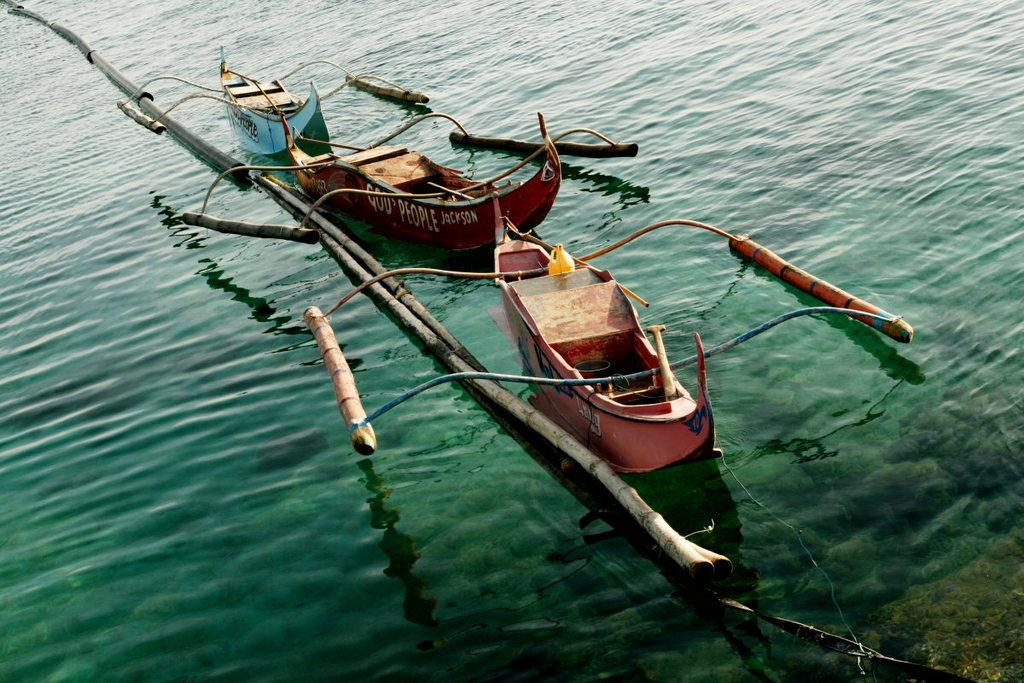How many boats are visible in the image? There are three boats in the image. Where are the boats located? The boats are on the water. What else can be seen near the boats? There are logs beside the boats. Where is the desk located in the image? There is no desk present in the image. What type of shoes are the people wearing in the image? There are no people or shoes visible in the image. 